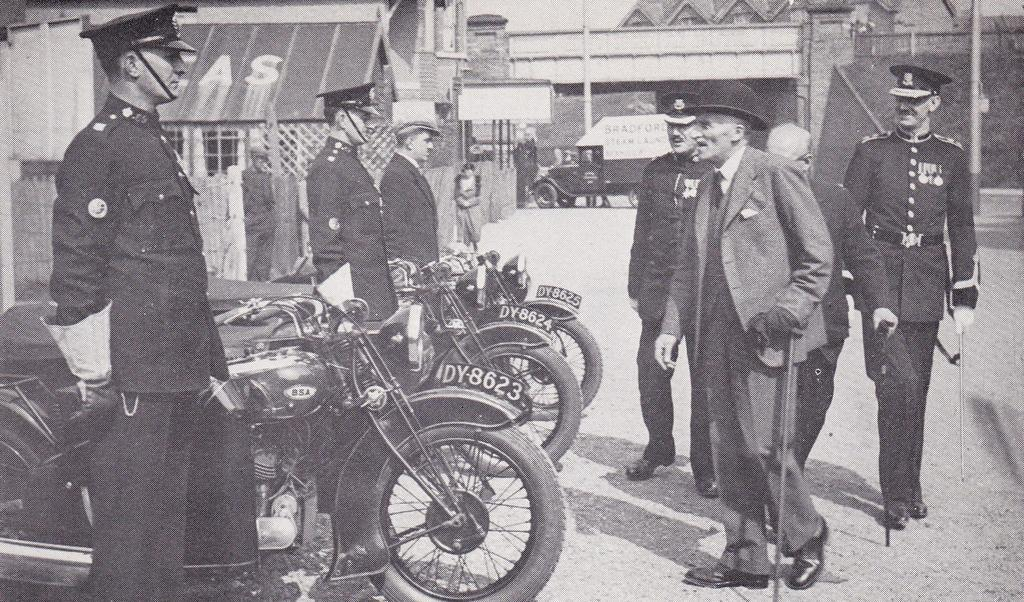Who or what can be seen in the image? There are people and motorcycles in the image. What type of vehicles are present in the image? There are motorcycles in the image. What else can be seen in the image besides people and motorcycles? There are houses in the image. Can you describe the background of the image? There is a truck in the background of the image. What type of spy equipment can be seen in the image? There is no spy equipment present in the image. What color is the pin on the person's shirt in the image? There is no pin visible on anyone's shirt in the image. 